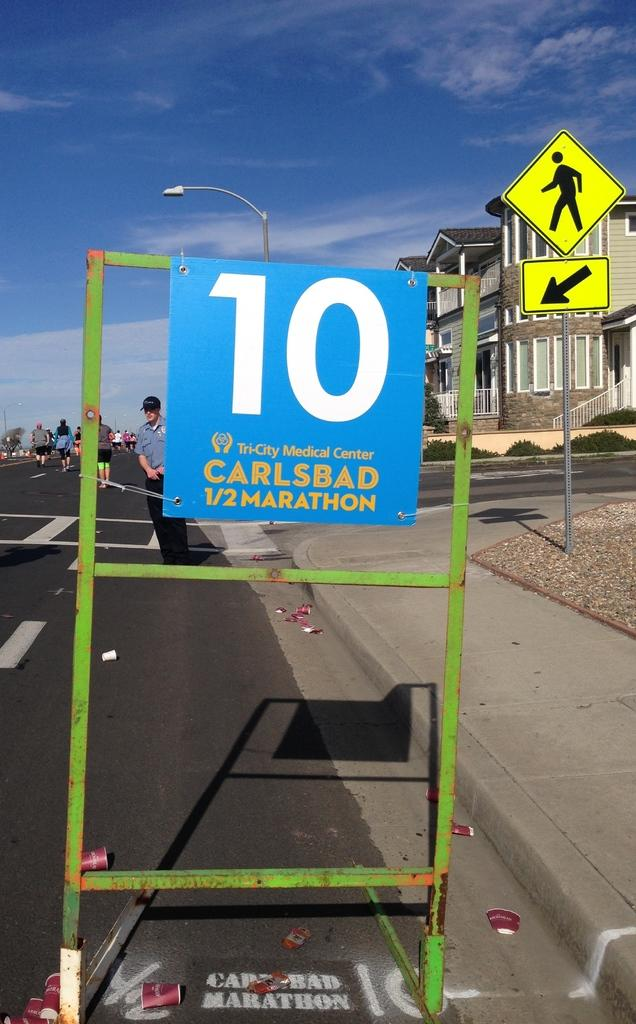<image>
Create a compact narrative representing the image presented. The Tri-City Medical Center is sponsoring the Carlsbad 1/3 Marathon. 